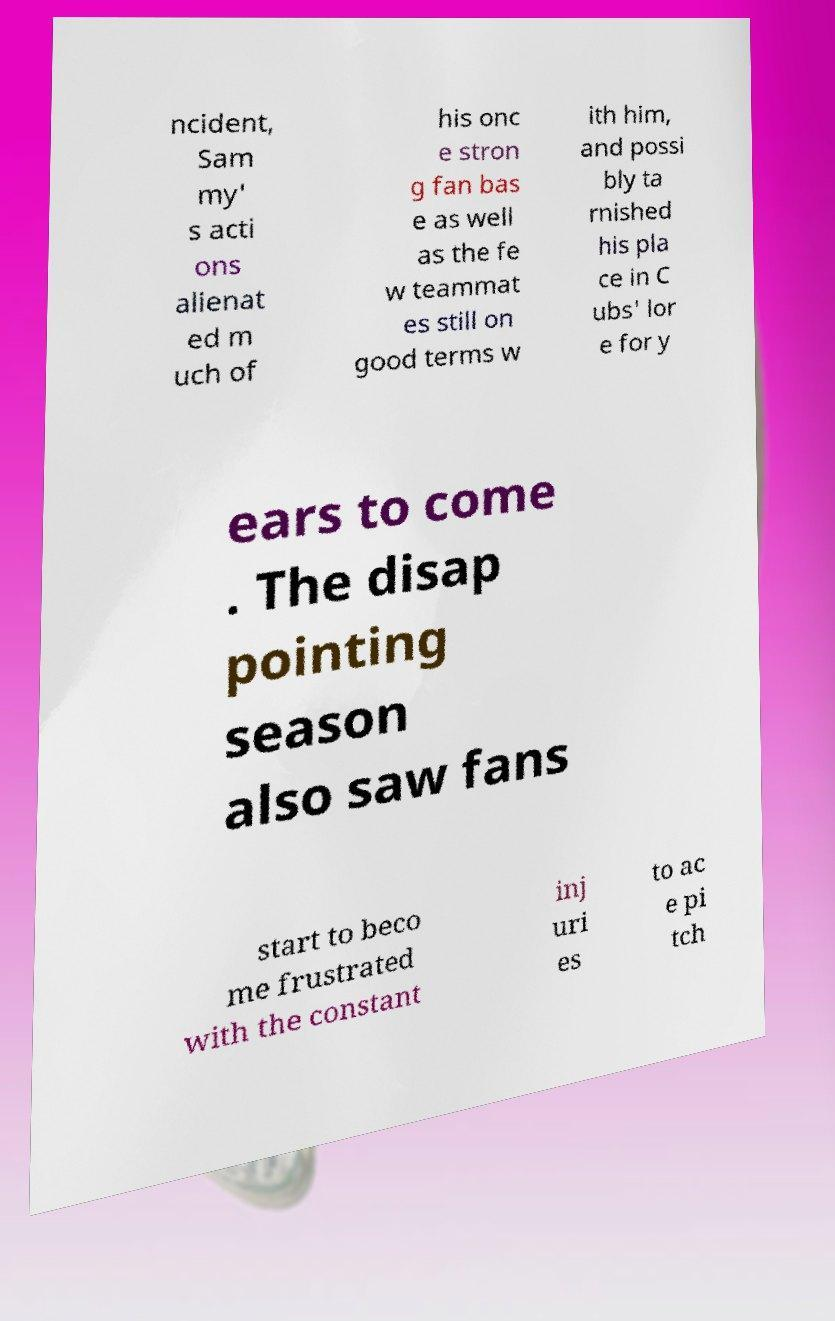I need the written content from this picture converted into text. Can you do that? ncident, Sam my' s acti ons alienat ed m uch of his onc e stron g fan bas e as well as the fe w teammat es still on good terms w ith him, and possi bly ta rnished his pla ce in C ubs' lor e for y ears to come . The disap pointing season also saw fans start to beco me frustrated with the constant inj uri es to ac e pi tch 